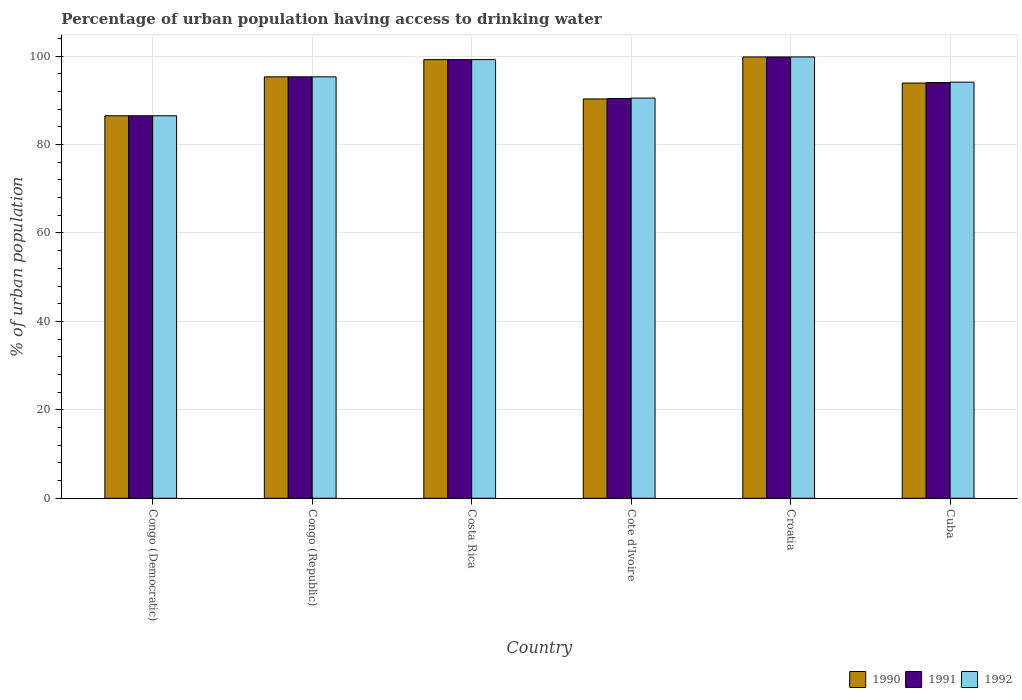How many different coloured bars are there?
Provide a succinct answer. 3. Are the number of bars per tick equal to the number of legend labels?
Offer a very short reply. Yes. Are the number of bars on each tick of the X-axis equal?
Your response must be concise. Yes. How many bars are there on the 3rd tick from the left?
Offer a terse response. 3. What is the label of the 4th group of bars from the left?
Your answer should be compact. Cote d'Ivoire. In how many cases, is the number of bars for a given country not equal to the number of legend labels?
Offer a terse response. 0. What is the percentage of urban population having access to drinking water in 1991 in Cote d'Ivoire?
Provide a succinct answer. 90.4. Across all countries, what is the maximum percentage of urban population having access to drinking water in 1992?
Offer a terse response. 99.8. Across all countries, what is the minimum percentage of urban population having access to drinking water in 1992?
Offer a very short reply. 86.5. In which country was the percentage of urban population having access to drinking water in 1990 maximum?
Your answer should be compact. Croatia. In which country was the percentage of urban population having access to drinking water in 1991 minimum?
Provide a succinct answer. Congo (Democratic). What is the total percentage of urban population having access to drinking water in 1990 in the graph?
Make the answer very short. 565. What is the difference between the percentage of urban population having access to drinking water in 1992 in Congo (Republic) and that in Cote d'Ivoire?
Your response must be concise. 4.8. What is the difference between the percentage of urban population having access to drinking water in 1991 in Cote d'Ivoire and the percentage of urban population having access to drinking water in 1990 in Costa Rica?
Keep it short and to the point. -8.8. What is the average percentage of urban population having access to drinking water in 1992 per country?
Offer a very short reply. 94.23. What is the difference between the percentage of urban population having access to drinking water of/in 1991 and percentage of urban population having access to drinking water of/in 1990 in Congo (Democratic)?
Make the answer very short. 0. What is the ratio of the percentage of urban population having access to drinking water in 1992 in Congo (Republic) to that in Costa Rica?
Offer a very short reply. 0.96. Is the percentage of urban population having access to drinking water in 1992 in Cote d'Ivoire less than that in Cuba?
Your response must be concise. Yes. What is the difference between the highest and the second highest percentage of urban population having access to drinking water in 1990?
Keep it short and to the point. -0.6. What is the difference between the highest and the lowest percentage of urban population having access to drinking water in 1990?
Provide a short and direct response. 13.3. Is it the case that in every country, the sum of the percentage of urban population having access to drinking water in 1992 and percentage of urban population having access to drinking water in 1991 is greater than the percentage of urban population having access to drinking water in 1990?
Keep it short and to the point. Yes. Are all the bars in the graph horizontal?
Your response must be concise. No. How many countries are there in the graph?
Offer a very short reply. 6. What is the difference between two consecutive major ticks on the Y-axis?
Your answer should be compact. 20. Where does the legend appear in the graph?
Give a very brief answer. Bottom right. What is the title of the graph?
Provide a short and direct response. Percentage of urban population having access to drinking water. What is the label or title of the X-axis?
Offer a very short reply. Country. What is the label or title of the Y-axis?
Give a very brief answer. % of urban population. What is the % of urban population of 1990 in Congo (Democratic)?
Your response must be concise. 86.5. What is the % of urban population of 1991 in Congo (Democratic)?
Provide a short and direct response. 86.5. What is the % of urban population of 1992 in Congo (Democratic)?
Ensure brevity in your answer.  86.5. What is the % of urban population of 1990 in Congo (Republic)?
Offer a very short reply. 95.3. What is the % of urban population in 1991 in Congo (Republic)?
Your response must be concise. 95.3. What is the % of urban population of 1992 in Congo (Republic)?
Offer a very short reply. 95.3. What is the % of urban population in 1990 in Costa Rica?
Ensure brevity in your answer.  99.2. What is the % of urban population in 1991 in Costa Rica?
Keep it short and to the point. 99.2. What is the % of urban population in 1992 in Costa Rica?
Provide a succinct answer. 99.2. What is the % of urban population in 1990 in Cote d'Ivoire?
Offer a terse response. 90.3. What is the % of urban population of 1991 in Cote d'Ivoire?
Provide a succinct answer. 90.4. What is the % of urban population of 1992 in Cote d'Ivoire?
Keep it short and to the point. 90.5. What is the % of urban population of 1990 in Croatia?
Ensure brevity in your answer.  99.8. What is the % of urban population of 1991 in Croatia?
Offer a very short reply. 99.8. What is the % of urban population of 1992 in Croatia?
Your answer should be compact. 99.8. What is the % of urban population of 1990 in Cuba?
Your answer should be very brief. 93.9. What is the % of urban population in 1991 in Cuba?
Ensure brevity in your answer.  94. What is the % of urban population in 1992 in Cuba?
Keep it short and to the point. 94.1. Across all countries, what is the maximum % of urban population of 1990?
Keep it short and to the point. 99.8. Across all countries, what is the maximum % of urban population in 1991?
Ensure brevity in your answer.  99.8. Across all countries, what is the maximum % of urban population in 1992?
Offer a very short reply. 99.8. Across all countries, what is the minimum % of urban population in 1990?
Your answer should be compact. 86.5. Across all countries, what is the minimum % of urban population in 1991?
Give a very brief answer. 86.5. Across all countries, what is the minimum % of urban population of 1992?
Keep it short and to the point. 86.5. What is the total % of urban population of 1990 in the graph?
Provide a short and direct response. 565. What is the total % of urban population of 1991 in the graph?
Your answer should be compact. 565.2. What is the total % of urban population in 1992 in the graph?
Keep it short and to the point. 565.4. What is the difference between the % of urban population of 1992 in Congo (Democratic) and that in Congo (Republic)?
Your response must be concise. -8.8. What is the difference between the % of urban population of 1992 in Congo (Democratic) and that in Costa Rica?
Offer a terse response. -12.7. What is the difference between the % of urban population in 1992 in Congo (Democratic) and that in Cote d'Ivoire?
Give a very brief answer. -4. What is the difference between the % of urban population in 1992 in Congo (Democratic) and that in Croatia?
Keep it short and to the point. -13.3. What is the difference between the % of urban population of 1991 in Congo (Democratic) and that in Cuba?
Ensure brevity in your answer.  -7.5. What is the difference between the % of urban population in 1992 in Congo (Democratic) and that in Cuba?
Your answer should be compact. -7.6. What is the difference between the % of urban population of 1990 in Congo (Republic) and that in Costa Rica?
Ensure brevity in your answer.  -3.9. What is the difference between the % of urban population of 1991 in Congo (Republic) and that in Costa Rica?
Make the answer very short. -3.9. What is the difference between the % of urban population in 1990 in Congo (Republic) and that in Cote d'Ivoire?
Give a very brief answer. 5. What is the difference between the % of urban population of 1992 in Congo (Republic) and that in Cote d'Ivoire?
Keep it short and to the point. 4.8. What is the difference between the % of urban population of 1990 in Congo (Republic) and that in Croatia?
Keep it short and to the point. -4.5. What is the difference between the % of urban population in 1991 in Congo (Republic) and that in Croatia?
Offer a very short reply. -4.5. What is the difference between the % of urban population of 1991 in Congo (Republic) and that in Cuba?
Provide a succinct answer. 1.3. What is the difference between the % of urban population of 1992 in Congo (Republic) and that in Cuba?
Keep it short and to the point. 1.2. What is the difference between the % of urban population of 1990 in Costa Rica and that in Cote d'Ivoire?
Ensure brevity in your answer.  8.9. What is the difference between the % of urban population of 1991 in Costa Rica and that in Cote d'Ivoire?
Make the answer very short. 8.8. What is the difference between the % of urban population in 1991 in Costa Rica and that in Croatia?
Offer a terse response. -0.6. What is the difference between the % of urban population of 1992 in Costa Rica and that in Croatia?
Your answer should be very brief. -0.6. What is the difference between the % of urban population of 1990 in Costa Rica and that in Cuba?
Your answer should be very brief. 5.3. What is the difference between the % of urban population of 1992 in Costa Rica and that in Cuba?
Offer a very short reply. 5.1. What is the difference between the % of urban population of 1990 in Cote d'Ivoire and that in Cuba?
Keep it short and to the point. -3.6. What is the difference between the % of urban population in 1990 in Croatia and that in Cuba?
Offer a terse response. 5.9. What is the difference between the % of urban population of 1991 in Congo (Democratic) and the % of urban population of 1992 in Congo (Republic)?
Your response must be concise. -8.8. What is the difference between the % of urban population of 1990 in Congo (Democratic) and the % of urban population of 1991 in Costa Rica?
Offer a very short reply. -12.7. What is the difference between the % of urban population in 1991 in Congo (Democratic) and the % of urban population in 1992 in Costa Rica?
Ensure brevity in your answer.  -12.7. What is the difference between the % of urban population in 1990 in Congo (Democratic) and the % of urban population in 1991 in Cote d'Ivoire?
Your answer should be compact. -3.9. What is the difference between the % of urban population of 1990 in Congo (Democratic) and the % of urban population of 1992 in Cote d'Ivoire?
Provide a succinct answer. -4. What is the difference between the % of urban population in 1991 in Congo (Democratic) and the % of urban population in 1992 in Cote d'Ivoire?
Your answer should be very brief. -4. What is the difference between the % of urban population of 1990 in Congo (Democratic) and the % of urban population of 1992 in Croatia?
Your answer should be very brief. -13.3. What is the difference between the % of urban population of 1990 in Congo (Democratic) and the % of urban population of 1991 in Cuba?
Your answer should be very brief. -7.5. What is the difference between the % of urban population in 1990 in Congo (Democratic) and the % of urban population in 1992 in Cuba?
Provide a succinct answer. -7.6. What is the difference between the % of urban population of 1991 in Congo (Republic) and the % of urban population of 1992 in Costa Rica?
Provide a short and direct response. -3.9. What is the difference between the % of urban population in 1990 in Congo (Republic) and the % of urban population in 1991 in Cote d'Ivoire?
Give a very brief answer. 4.9. What is the difference between the % of urban population of 1991 in Congo (Republic) and the % of urban population of 1992 in Cote d'Ivoire?
Keep it short and to the point. 4.8. What is the difference between the % of urban population in 1990 in Congo (Republic) and the % of urban population in 1992 in Croatia?
Ensure brevity in your answer.  -4.5. What is the difference between the % of urban population in 1991 in Congo (Republic) and the % of urban population in 1992 in Croatia?
Provide a short and direct response. -4.5. What is the difference between the % of urban population of 1990 in Congo (Republic) and the % of urban population of 1992 in Cuba?
Ensure brevity in your answer.  1.2. What is the difference between the % of urban population of 1991 in Congo (Republic) and the % of urban population of 1992 in Cuba?
Provide a short and direct response. 1.2. What is the difference between the % of urban population in 1991 in Costa Rica and the % of urban population in 1992 in Cote d'Ivoire?
Provide a succinct answer. 8.7. What is the difference between the % of urban population of 1990 in Costa Rica and the % of urban population of 1992 in Croatia?
Your answer should be very brief. -0.6. What is the difference between the % of urban population of 1990 in Costa Rica and the % of urban population of 1991 in Cuba?
Make the answer very short. 5.2. What is the difference between the % of urban population in 1990 in Costa Rica and the % of urban population in 1992 in Cuba?
Ensure brevity in your answer.  5.1. What is the difference between the % of urban population in 1990 in Croatia and the % of urban population in 1991 in Cuba?
Your answer should be very brief. 5.8. What is the difference between the % of urban population in 1991 in Croatia and the % of urban population in 1992 in Cuba?
Provide a short and direct response. 5.7. What is the average % of urban population in 1990 per country?
Give a very brief answer. 94.17. What is the average % of urban population of 1991 per country?
Your answer should be compact. 94.2. What is the average % of urban population of 1992 per country?
Provide a succinct answer. 94.23. What is the difference between the % of urban population in 1990 and % of urban population in 1992 in Congo (Democratic)?
Provide a succinct answer. 0. What is the difference between the % of urban population in 1991 and % of urban population in 1992 in Congo (Democratic)?
Provide a short and direct response. 0. What is the difference between the % of urban population in 1991 and % of urban population in 1992 in Congo (Republic)?
Provide a succinct answer. 0. What is the difference between the % of urban population in 1991 and % of urban population in 1992 in Costa Rica?
Your answer should be compact. 0. What is the difference between the % of urban population of 1991 and % of urban population of 1992 in Cote d'Ivoire?
Keep it short and to the point. -0.1. What is the difference between the % of urban population in 1990 and % of urban population in 1991 in Croatia?
Your answer should be very brief. 0. What is the difference between the % of urban population of 1990 and % of urban population of 1992 in Croatia?
Offer a very short reply. 0. What is the difference between the % of urban population of 1990 and % of urban population of 1992 in Cuba?
Provide a short and direct response. -0.2. What is the ratio of the % of urban population in 1990 in Congo (Democratic) to that in Congo (Republic)?
Provide a short and direct response. 0.91. What is the ratio of the % of urban population of 1991 in Congo (Democratic) to that in Congo (Republic)?
Give a very brief answer. 0.91. What is the ratio of the % of urban population in 1992 in Congo (Democratic) to that in Congo (Republic)?
Keep it short and to the point. 0.91. What is the ratio of the % of urban population in 1990 in Congo (Democratic) to that in Costa Rica?
Your answer should be compact. 0.87. What is the ratio of the % of urban population in 1991 in Congo (Democratic) to that in Costa Rica?
Provide a succinct answer. 0.87. What is the ratio of the % of urban population in 1992 in Congo (Democratic) to that in Costa Rica?
Give a very brief answer. 0.87. What is the ratio of the % of urban population in 1990 in Congo (Democratic) to that in Cote d'Ivoire?
Your answer should be very brief. 0.96. What is the ratio of the % of urban population of 1991 in Congo (Democratic) to that in Cote d'Ivoire?
Your answer should be very brief. 0.96. What is the ratio of the % of urban population of 1992 in Congo (Democratic) to that in Cote d'Ivoire?
Your answer should be very brief. 0.96. What is the ratio of the % of urban population of 1990 in Congo (Democratic) to that in Croatia?
Make the answer very short. 0.87. What is the ratio of the % of urban population of 1991 in Congo (Democratic) to that in Croatia?
Provide a succinct answer. 0.87. What is the ratio of the % of urban population of 1992 in Congo (Democratic) to that in Croatia?
Provide a succinct answer. 0.87. What is the ratio of the % of urban population of 1990 in Congo (Democratic) to that in Cuba?
Provide a short and direct response. 0.92. What is the ratio of the % of urban population of 1991 in Congo (Democratic) to that in Cuba?
Make the answer very short. 0.92. What is the ratio of the % of urban population of 1992 in Congo (Democratic) to that in Cuba?
Keep it short and to the point. 0.92. What is the ratio of the % of urban population of 1990 in Congo (Republic) to that in Costa Rica?
Offer a very short reply. 0.96. What is the ratio of the % of urban population of 1991 in Congo (Republic) to that in Costa Rica?
Offer a terse response. 0.96. What is the ratio of the % of urban population in 1992 in Congo (Republic) to that in Costa Rica?
Offer a very short reply. 0.96. What is the ratio of the % of urban population of 1990 in Congo (Republic) to that in Cote d'Ivoire?
Provide a short and direct response. 1.06. What is the ratio of the % of urban population of 1991 in Congo (Republic) to that in Cote d'Ivoire?
Provide a succinct answer. 1.05. What is the ratio of the % of urban population of 1992 in Congo (Republic) to that in Cote d'Ivoire?
Make the answer very short. 1.05. What is the ratio of the % of urban population in 1990 in Congo (Republic) to that in Croatia?
Provide a short and direct response. 0.95. What is the ratio of the % of urban population of 1991 in Congo (Republic) to that in Croatia?
Your answer should be very brief. 0.95. What is the ratio of the % of urban population in 1992 in Congo (Republic) to that in Croatia?
Ensure brevity in your answer.  0.95. What is the ratio of the % of urban population in 1990 in Congo (Republic) to that in Cuba?
Ensure brevity in your answer.  1.01. What is the ratio of the % of urban population of 1991 in Congo (Republic) to that in Cuba?
Give a very brief answer. 1.01. What is the ratio of the % of urban population in 1992 in Congo (Republic) to that in Cuba?
Keep it short and to the point. 1.01. What is the ratio of the % of urban population of 1990 in Costa Rica to that in Cote d'Ivoire?
Your answer should be very brief. 1.1. What is the ratio of the % of urban population in 1991 in Costa Rica to that in Cote d'Ivoire?
Offer a terse response. 1.1. What is the ratio of the % of urban population in 1992 in Costa Rica to that in Cote d'Ivoire?
Offer a terse response. 1.1. What is the ratio of the % of urban population of 1990 in Costa Rica to that in Croatia?
Offer a terse response. 0.99. What is the ratio of the % of urban population of 1991 in Costa Rica to that in Croatia?
Make the answer very short. 0.99. What is the ratio of the % of urban population in 1990 in Costa Rica to that in Cuba?
Give a very brief answer. 1.06. What is the ratio of the % of urban population of 1991 in Costa Rica to that in Cuba?
Offer a terse response. 1.06. What is the ratio of the % of urban population in 1992 in Costa Rica to that in Cuba?
Your response must be concise. 1.05. What is the ratio of the % of urban population in 1990 in Cote d'Ivoire to that in Croatia?
Ensure brevity in your answer.  0.9. What is the ratio of the % of urban population of 1991 in Cote d'Ivoire to that in Croatia?
Make the answer very short. 0.91. What is the ratio of the % of urban population of 1992 in Cote d'Ivoire to that in Croatia?
Offer a terse response. 0.91. What is the ratio of the % of urban population of 1990 in Cote d'Ivoire to that in Cuba?
Provide a succinct answer. 0.96. What is the ratio of the % of urban population in 1991 in Cote d'Ivoire to that in Cuba?
Provide a short and direct response. 0.96. What is the ratio of the % of urban population of 1992 in Cote d'Ivoire to that in Cuba?
Give a very brief answer. 0.96. What is the ratio of the % of urban population of 1990 in Croatia to that in Cuba?
Offer a terse response. 1.06. What is the ratio of the % of urban population of 1991 in Croatia to that in Cuba?
Give a very brief answer. 1.06. What is the ratio of the % of urban population in 1992 in Croatia to that in Cuba?
Offer a terse response. 1.06. What is the difference between the highest and the second highest % of urban population in 1990?
Offer a very short reply. 0.6. What is the difference between the highest and the second highest % of urban population in 1992?
Provide a short and direct response. 0.6. What is the difference between the highest and the lowest % of urban population of 1990?
Your answer should be compact. 13.3. What is the difference between the highest and the lowest % of urban population in 1991?
Make the answer very short. 13.3. 